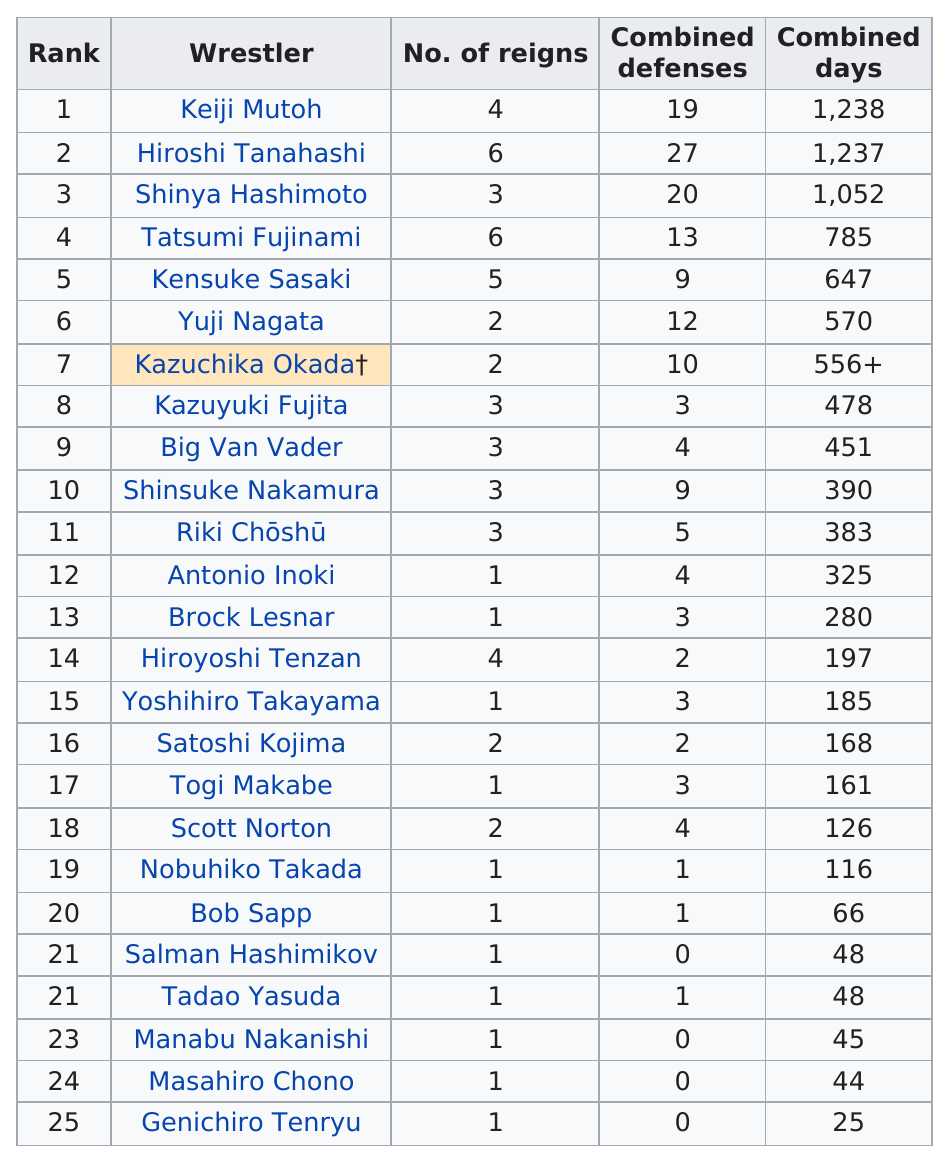Give some essential details in this illustration. Hiroshi Tanahashi, a renowned wrestler, holds the record for the most combined defenses in professional wrestling. Yuji Nagata has a combined defense of 12. The difference between the highest and lowest military rank defense is 1,219. Hiroyoshi Tenzan, Salman Hashimikov, Manabu Nakanishi, Masahiro Chono, and Genichiro Tenryu are professional wrestlers who have collectively held more reigns as champions than they have combined defenses. Each of these wrestlers, including Shinya Hashimoto, Kazuyuki Fujita, Big Van Vader, Shinsuke Nakamura, and Riki Chōshū, came from a reign of 3. 